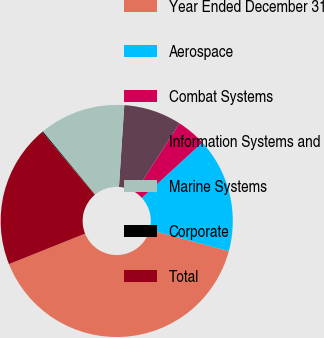Convert chart. <chart><loc_0><loc_0><loc_500><loc_500><pie_chart><fcel>Year Ended December 31<fcel>Aerospace<fcel>Combat Systems<fcel>Information Systems and<fcel>Marine Systems<fcel>Corporate<fcel>Total<nl><fcel>39.75%<fcel>15.98%<fcel>4.1%<fcel>8.06%<fcel>12.02%<fcel>0.14%<fcel>19.94%<nl></chart> 